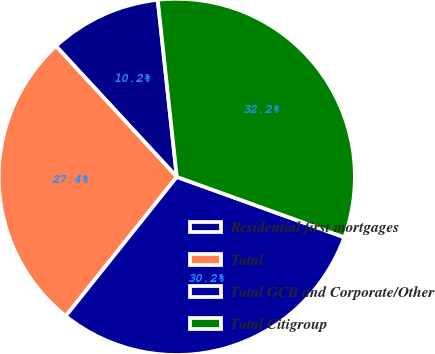Convert chart. <chart><loc_0><loc_0><loc_500><loc_500><pie_chart><fcel>Residential first mortgages<fcel>Total<fcel>Total GCB and Corporate/Other<fcel>Total Citigroup<nl><fcel>10.16%<fcel>27.41%<fcel>30.21%<fcel>32.21%<nl></chart> 